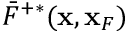Convert formula to latex. <formula><loc_0><loc_0><loc_500><loc_500>\bar { F } ^ { + * } ( { x } , { x } _ { F } )</formula> 